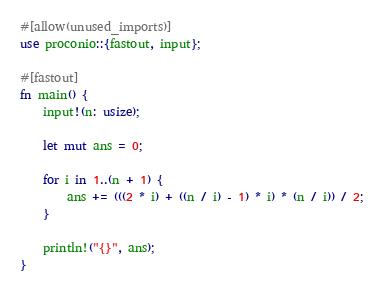Convert code to text. <code><loc_0><loc_0><loc_500><loc_500><_Rust_>#[allow(unused_imports)]
use proconio::{fastout, input};

#[fastout]
fn main() {
    input!(n: usize);

    let mut ans = 0;

    for i in 1..(n + 1) {
        ans += (((2 * i) + ((n / i) - 1) * i) * (n / i)) / 2;
    }

    println!("{}", ans);
}
</code> 